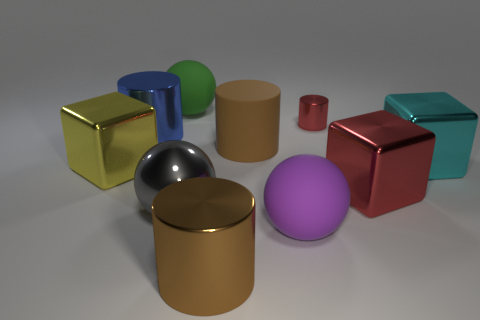Are there any other things that are the same size as the red cylinder?
Make the answer very short. No. How many things are the same color as the large matte cylinder?
Provide a succinct answer. 1. What number of cylinders are in front of the large yellow metal object that is behind the big shiny ball?
Your response must be concise. 1. How many cylinders are tiny green rubber things or small red objects?
Your response must be concise. 1. Is there a large purple rubber ball?
Make the answer very short. Yes. What size is the other rubber object that is the same shape as the large green object?
Offer a very short reply. Large. There is a big blue shiny thing that is right of the shiny block that is to the left of the big purple object; what is its shape?
Provide a succinct answer. Cylinder. What number of green things are metallic balls or balls?
Your answer should be very brief. 1. The rubber cylinder has what color?
Your response must be concise. Brown. Is the size of the brown rubber thing the same as the gray thing?
Offer a terse response. Yes. 